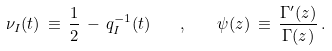<formula> <loc_0><loc_0><loc_500><loc_500>\nu _ { I } ( t ) \, \equiv \, \frac { 1 } { 2 } \, - \, q _ { I } ^ { - 1 } ( t ) \quad , \quad \psi ( z ) \, \equiv \, \frac { \Gamma ^ { \prime } ( z ) } { \Gamma ( z ) } \, .</formula> 